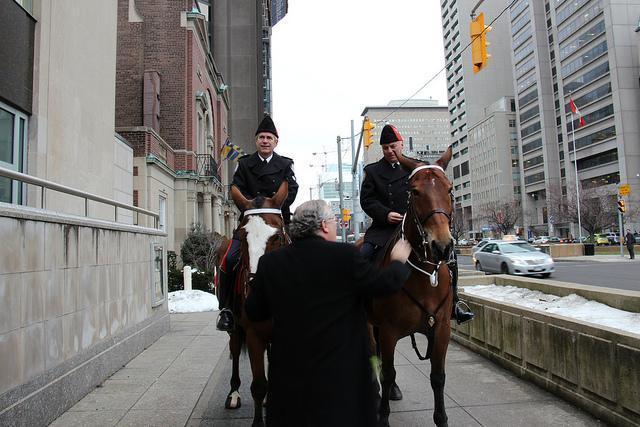How many horses are there?
Give a very brief answer. 2. How many people can you see?
Give a very brief answer. 3. 